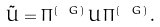Convert formula to latex. <formula><loc_0><loc_0><loc_500><loc_500>\tilde { U } = \Pi ^ { ( \ G ) } \, U \, \Pi ^ { ( \ G ) } \, .</formula> 